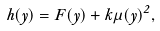Convert formula to latex. <formula><loc_0><loc_0><loc_500><loc_500>h ( y ) = F ( y ) + k \mu ( y ) ^ { 2 } ,</formula> 